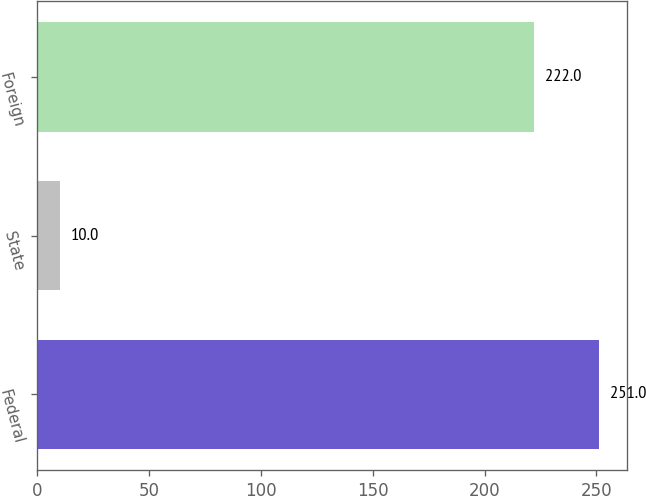Convert chart. <chart><loc_0><loc_0><loc_500><loc_500><bar_chart><fcel>Federal<fcel>State<fcel>Foreign<nl><fcel>251<fcel>10<fcel>222<nl></chart> 